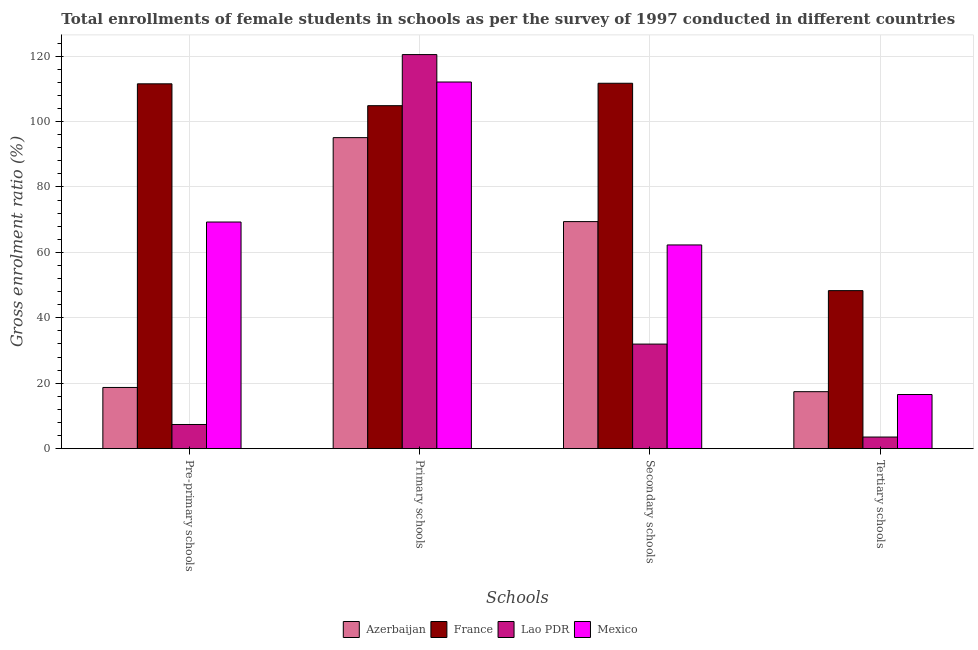Are the number of bars per tick equal to the number of legend labels?
Provide a succinct answer. Yes. Are the number of bars on each tick of the X-axis equal?
Offer a terse response. Yes. What is the label of the 3rd group of bars from the left?
Your answer should be very brief. Secondary schools. What is the gross enrolment ratio(female) in pre-primary schools in Azerbaijan?
Offer a terse response. 18.71. Across all countries, what is the maximum gross enrolment ratio(female) in tertiary schools?
Your answer should be very brief. 48.31. Across all countries, what is the minimum gross enrolment ratio(female) in primary schools?
Keep it short and to the point. 95.08. In which country was the gross enrolment ratio(female) in primary schools maximum?
Ensure brevity in your answer.  Lao PDR. In which country was the gross enrolment ratio(female) in secondary schools minimum?
Your answer should be compact. Lao PDR. What is the total gross enrolment ratio(female) in tertiary schools in the graph?
Make the answer very short. 85.84. What is the difference between the gross enrolment ratio(female) in pre-primary schools in Mexico and that in Azerbaijan?
Your answer should be compact. 50.57. What is the difference between the gross enrolment ratio(female) in secondary schools in France and the gross enrolment ratio(female) in pre-primary schools in Azerbaijan?
Your answer should be very brief. 92.99. What is the average gross enrolment ratio(female) in pre-primary schools per country?
Offer a very short reply. 51.73. What is the difference between the gross enrolment ratio(female) in secondary schools and gross enrolment ratio(female) in pre-primary schools in Azerbaijan?
Give a very brief answer. 50.7. In how many countries, is the gross enrolment ratio(female) in tertiary schools greater than 104 %?
Your response must be concise. 0. What is the ratio of the gross enrolment ratio(female) in secondary schools in Mexico to that in France?
Make the answer very short. 0.56. Is the gross enrolment ratio(female) in primary schools in Mexico less than that in France?
Keep it short and to the point. No. Is the difference between the gross enrolment ratio(female) in pre-primary schools in Azerbaijan and Mexico greater than the difference between the gross enrolment ratio(female) in secondary schools in Azerbaijan and Mexico?
Offer a very short reply. No. What is the difference between the highest and the second highest gross enrolment ratio(female) in secondary schools?
Make the answer very short. 42.29. What is the difference between the highest and the lowest gross enrolment ratio(female) in pre-primary schools?
Make the answer very short. 104.14. In how many countries, is the gross enrolment ratio(female) in secondary schools greater than the average gross enrolment ratio(female) in secondary schools taken over all countries?
Offer a terse response. 2. What does the 1st bar from the left in Pre-primary schools represents?
Ensure brevity in your answer.  Azerbaijan. What does the 2nd bar from the right in Secondary schools represents?
Provide a short and direct response. Lao PDR. Is it the case that in every country, the sum of the gross enrolment ratio(female) in pre-primary schools and gross enrolment ratio(female) in primary schools is greater than the gross enrolment ratio(female) in secondary schools?
Your response must be concise. Yes. How many bars are there?
Offer a terse response. 16. How many countries are there in the graph?
Offer a very short reply. 4. Are the values on the major ticks of Y-axis written in scientific E-notation?
Ensure brevity in your answer.  No. Does the graph contain grids?
Your answer should be very brief. Yes. Where does the legend appear in the graph?
Provide a short and direct response. Bottom center. How many legend labels are there?
Offer a very short reply. 4. How are the legend labels stacked?
Provide a short and direct response. Horizontal. What is the title of the graph?
Give a very brief answer. Total enrollments of female students in schools as per the survey of 1997 conducted in different countries. Does "Moldova" appear as one of the legend labels in the graph?
Provide a short and direct response. No. What is the label or title of the X-axis?
Ensure brevity in your answer.  Schools. What is the label or title of the Y-axis?
Your answer should be compact. Gross enrolment ratio (%). What is the Gross enrolment ratio (%) of Azerbaijan in Pre-primary schools?
Provide a succinct answer. 18.71. What is the Gross enrolment ratio (%) in France in Pre-primary schools?
Provide a short and direct response. 111.53. What is the Gross enrolment ratio (%) in Lao PDR in Pre-primary schools?
Provide a short and direct response. 7.39. What is the Gross enrolment ratio (%) of Mexico in Pre-primary schools?
Offer a very short reply. 69.28. What is the Gross enrolment ratio (%) of Azerbaijan in Primary schools?
Your response must be concise. 95.08. What is the Gross enrolment ratio (%) of France in Primary schools?
Your answer should be very brief. 104.85. What is the Gross enrolment ratio (%) in Lao PDR in Primary schools?
Keep it short and to the point. 120.47. What is the Gross enrolment ratio (%) in Mexico in Primary schools?
Provide a short and direct response. 112.09. What is the Gross enrolment ratio (%) in Azerbaijan in Secondary schools?
Your answer should be very brief. 69.41. What is the Gross enrolment ratio (%) in France in Secondary schools?
Offer a terse response. 111.7. What is the Gross enrolment ratio (%) of Lao PDR in Secondary schools?
Make the answer very short. 31.97. What is the Gross enrolment ratio (%) of Mexico in Secondary schools?
Keep it short and to the point. 62.28. What is the Gross enrolment ratio (%) in Azerbaijan in Tertiary schools?
Provide a short and direct response. 17.43. What is the Gross enrolment ratio (%) in France in Tertiary schools?
Provide a succinct answer. 48.31. What is the Gross enrolment ratio (%) of Lao PDR in Tertiary schools?
Offer a very short reply. 3.56. What is the Gross enrolment ratio (%) in Mexico in Tertiary schools?
Your answer should be very brief. 16.55. Across all Schools, what is the maximum Gross enrolment ratio (%) of Azerbaijan?
Your answer should be compact. 95.08. Across all Schools, what is the maximum Gross enrolment ratio (%) in France?
Your response must be concise. 111.7. Across all Schools, what is the maximum Gross enrolment ratio (%) of Lao PDR?
Offer a terse response. 120.47. Across all Schools, what is the maximum Gross enrolment ratio (%) of Mexico?
Provide a succinct answer. 112.09. Across all Schools, what is the minimum Gross enrolment ratio (%) of Azerbaijan?
Provide a succinct answer. 17.43. Across all Schools, what is the minimum Gross enrolment ratio (%) in France?
Your response must be concise. 48.31. Across all Schools, what is the minimum Gross enrolment ratio (%) in Lao PDR?
Ensure brevity in your answer.  3.56. Across all Schools, what is the minimum Gross enrolment ratio (%) of Mexico?
Provide a succinct answer. 16.55. What is the total Gross enrolment ratio (%) in Azerbaijan in the graph?
Your answer should be very brief. 200.63. What is the total Gross enrolment ratio (%) in France in the graph?
Your response must be concise. 376.4. What is the total Gross enrolment ratio (%) of Lao PDR in the graph?
Offer a terse response. 163.39. What is the total Gross enrolment ratio (%) in Mexico in the graph?
Your answer should be very brief. 260.2. What is the difference between the Gross enrolment ratio (%) in Azerbaijan in Pre-primary schools and that in Primary schools?
Your answer should be compact. -76.37. What is the difference between the Gross enrolment ratio (%) in France in Pre-primary schools and that in Primary schools?
Ensure brevity in your answer.  6.68. What is the difference between the Gross enrolment ratio (%) in Lao PDR in Pre-primary schools and that in Primary schools?
Keep it short and to the point. -113.08. What is the difference between the Gross enrolment ratio (%) of Mexico in Pre-primary schools and that in Primary schools?
Offer a very short reply. -42.8. What is the difference between the Gross enrolment ratio (%) in Azerbaijan in Pre-primary schools and that in Secondary schools?
Offer a very short reply. -50.7. What is the difference between the Gross enrolment ratio (%) of France in Pre-primary schools and that in Secondary schools?
Keep it short and to the point. -0.17. What is the difference between the Gross enrolment ratio (%) of Lao PDR in Pre-primary schools and that in Secondary schools?
Your response must be concise. -24.58. What is the difference between the Gross enrolment ratio (%) of Mexico in Pre-primary schools and that in Secondary schools?
Give a very brief answer. 7.01. What is the difference between the Gross enrolment ratio (%) of Azerbaijan in Pre-primary schools and that in Tertiary schools?
Give a very brief answer. 1.29. What is the difference between the Gross enrolment ratio (%) in France in Pre-primary schools and that in Tertiary schools?
Give a very brief answer. 63.22. What is the difference between the Gross enrolment ratio (%) in Lao PDR in Pre-primary schools and that in Tertiary schools?
Your response must be concise. 3.84. What is the difference between the Gross enrolment ratio (%) of Mexico in Pre-primary schools and that in Tertiary schools?
Your answer should be very brief. 52.73. What is the difference between the Gross enrolment ratio (%) in Azerbaijan in Primary schools and that in Secondary schools?
Keep it short and to the point. 25.67. What is the difference between the Gross enrolment ratio (%) of France in Primary schools and that in Secondary schools?
Keep it short and to the point. -6.85. What is the difference between the Gross enrolment ratio (%) in Lao PDR in Primary schools and that in Secondary schools?
Keep it short and to the point. 88.5. What is the difference between the Gross enrolment ratio (%) of Mexico in Primary schools and that in Secondary schools?
Provide a succinct answer. 49.81. What is the difference between the Gross enrolment ratio (%) in Azerbaijan in Primary schools and that in Tertiary schools?
Offer a very short reply. 77.66. What is the difference between the Gross enrolment ratio (%) of France in Primary schools and that in Tertiary schools?
Ensure brevity in your answer.  56.54. What is the difference between the Gross enrolment ratio (%) of Lao PDR in Primary schools and that in Tertiary schools?
Offer a terse response. 116.91. What is the difference between the Gross enrolment ratio (%) of Mexico in Primary schools and that in Tertiary schools?
Your response must be concise. 95.53. What is the difference between the Gross enrolment ratio (%) in Azerbaijan in Secondary schools and that in Tertiary schools?
Offer a terse response. 51.99. What is the difference between the Gross enrolment ratio (%) of France in Secondary schools and that in Tertiary schools?
Your answer should be very brief. 63.39. What is the difference between the Gross enrolment ratio (%) of Lao PDR in Secondary schools and that in Tertiary schools?
Your response must be concise. 28.42. What is the difference between the Gross enrolment ratio (%) of Mexico in Secondary schools and that in Tertiary schools?
Your answer should be compact. 45.73. What is the difference between the Gross enrolment ratio (%) in Azerbaijan in Pre-primary schools and the Gross enrolment ratio (%) in France in Primary schools?
Ensure brevity in your answer.  -86.14. What is the difference between the Gross enrolment ratio (%) of Azerbaijan in Pre-primary schools and the Gross enrolment ratio (%) of Lao PDR in Primary schools?
Make the answer very short. -101.76. What is the difference between the Gross enrolment ratio (%) of Azerbaijan in Pre-primary schools and the Gross enrolment ratio (%) of Mexico in Primary schools?
Provide a short and direct response. -93.38. What is the difference between the Gross enrolment ratio (%) in France in Pre-primary schools and the Gross enrolment ratio (%) in Lao PDR in Primary schools?
Make the answer very short. -8.94. What is the difference between the Gross enrolment ratio (%) of France in Pre-primary schools and the Gross enrolment ratio (%) of Mexico in Primary schools?
Give a very brief answer. -0.56. What is the difference between the Gross enrolment ratio (%) in Lao PDR in Pre-primary schools and the Gross enrolment ratio (%) in Mexico in Primary schools?
Your answer should be very brief. -104.69. What is the difference between the Gross enrolment ratio (%) of Azerbaijan in Pre-primary schools and the Gross enrolment ratio (%) of France in Secondary schools?
Offer a very short reply. -92.99. What is the difference between the Gross enrolment ratio (%) of Azerbaijan in Pre-primary schools and the Gross enrolment ratio (%) of Lao PDR in Secondary schools?
Your response must be concise. -13.26. What is the difference between the Gross enrolment ratio (%) of Azerbaijan in Pre-primary schools and the Gross enrolment ratio (%) of Mexico in Secondary schools?
Provide a succinct answer. -43.57. What is the difference between the Gross enrolment ratio (%) of France in Pre-primary schools and the Gross enrolment ratio (%) of Lao PDR in Secondary schools?
Make the answer very short. 79.56. What is the difference between the Gross enrolment ratio (%) in France in Pre-primary schools and the Gross enrolment ratio (%) in Mexico in Secondary schools?
Provide a short and direct response. 49.25. What is the difference between the Gross enrolment ratio (%) of Lao PDR in Pre-primary schools and the Gross enrolment ratio (%) of Mexico in Secondary schools?
Offer a very short reply. -54.88. What is the difference between the Gross enrolment ratio (%) of Azerbaijan in Pre-primary schools and the Gross enrolment ratio (%) of France in Tertiary schools?
Make the answer very short. -29.6. What is the difference between the Gross enrolment ratio (%) of Azerbaijan in Pre-primary schools and the Gross enrolment ratio (%) of Lao PDR in Tertiary schools?
Ensure brevity in your answer.  15.16. What is the difference between the Gross enrolment ratio (%) in Azerbaijan in Pre-primary schools and the Gross enrolment ratio (%) in Mexico in Tertiary schools?
Provide a succinct answer. 2.16. What is the difference between the Gross enrolment ratio (%) in France in Pre-primary schools and the Gross enrolment ratio (%) in Lao PDR in Tertiary schools?
Ensure brevity in your answer.  107.98. What is the difference between the Gross enrolment ratio (%) of France in Pre-primary schools and the Gross enrolment ratio (%) of Mexico in Tertiary schools?
Provide a succinct answer. 94.98. What is the difference between the Gross enrolment ratio (%) in Lao PDR in Pre-primary schools and the Gross enrolment ratio (%) in Mexico in Tertiary schools?
Ensure brevity in your answer.  -9.16. What is the difference between the Gross enrolment ratio (%) in Azerbaijan in Primary schools and the Gross enrolment ratio (%) in France in Secondary schools?
Offer a very short reply. -16.62. What is the difference between the Gross enrolment ratio (%) in Azerbaijan in Primary schools and the Gross enrolment ratio (%) in Lao PDR in Secondary schools?
Provide a succinct answer. 63.11. What is the difference between the Gross enrolment ratio (%) in Azerbaijan in Primary schools and the Gross enrolment ratio (%) in Mexico in Secondary schools?
Give a very brief answer. 32.81. What is the difference between the Gross enrolment ratio (%) in France in Primary schools and the Gross enrolment ratio (%) in Lao PDR in Secondary schools?
Your response must be concise. 72.88. What is the difference between the Gross enrolment ratio (%) of France in Primary schools and the Gross enrolment ratio (%) of Mexico in Secondary schools?
Your answer should be very brief. 42.57. What is the difference between the Gross enrolment ratio (%) of Lao PDR in Primary schools and the Gross enrolment ratio (%) of Mexico in Secondary schools?
Provide a succinct answer. 58.19. What is the difference between the Gross enrolment ratio (%) of Azerbaijan in Primary schools and the Gross enrolment ratio (%) of France in Tertiary schools?
Make the answer very short. 46.77. What is the difference between the Gross enrolment ratio (%) of Azerbaijan in Primary schools and the Gross enrolment ratio (%) of Lao PDR in Tertiary schools?
Your response must be concise. 91.53. What is the difference between the Gross enrolment ratio (%) in Azerbaijan in Primary schools and the Gross enrolment ratio (%) in Mexico in Tertiary schools?
Keep it short and to the point. 78.53. What is the difference between the Gross enrolment ratio (%) in France in Primary schools and the Gross enrolment ratio (%) in Lao PDR in Tertiary schools?
Make the answer very short. 101.29. What is the difference between the Gross enrolment ratio (%) of France in Primary schools and the Gross enrolment ratio (%) of Mexico in Tertiary schools?
Your answer should be compact. 88.3. What is the difference between the Gross enrolment ratio (%) of Lao PDR in Primary schools and the Gross enrolment ratio (%) of Mexico in Tertiary schools?
Offer a terse response. 103.92. What is the difference between the Gross enrolment ratio (%) in Azerbaijan in Secondary schools and the Gross enrolment ratio (%) in France in Tertiary schools?
Give a very brief answer. 21.1. What is the difference between the Gross enrolment ratio (%) in Azerbaijan in Secondary schools and the Gross enrolment ratio (%) in Lao PDR in Tertiary schools?
Your answer should be compact. 65.86. What is the difference between the Gross enrolment ratio (%) of Azerbaijan in Secondary schools and the Gross enrolment ratio (%) of Mexico in Tertiary schools?
Keep it short and to the point. 52.86. What is the difference between the Gross enrolment ratio (%) of France in Secondary schools and the Gross enrolment ratio (%) of Lao PDR in Tertiary schools?
Provide a short and direct response. 108.15. What is the difference between the Gross enrolment ratio (%) in France in Secondary schools and the Gross enrolment ratio (%) in Mexico in Tertiary schools?
Your response must be concise. 95.15. What is the difference between the Gross enrolment ratio (%) in Lao PDR in Secondary schools and the Gross enrolment ratio (%) in Mexico in Tertiary schools?
Make the answer very short. 15.42. What is the average Gross enrolment ratio (%) of Azerbaijan per Schools?
Your answer should be compact. 50.16. What is the average Gross enrolment ratio (%) in France per Schools?
Give a very brief answer. 94.1. What is the average Gross enrolment ratio (%) in Lao PDR per Schools?
Your answer should be compact. 40.85. What is the average Gross enrolment ratio (%) of Mexico per Schools?
Your answer should be very brief. 65.05. What is the difference between the Gross enrolment ratio (%) of Azerbaijan and Gross enrolment ratio (%) of France in Pre-primary schools?
Your response must be concise. -92.82. What is the difference between the Gross enrolment ratio (%) in Azerbaijan and Gross enrolment ratio (%) in Lao PDR in Pre-primary schools?
Your answer should be very brief. 11.32. What is the difference between the Gross enrolment ratio (%) of Azerbaijan and Gross enrolment ratio (%) of Mexico in Pre-primary schools?
Offer a terse response. -50.57. What is the difference between the Gross enrolment ratio (%) of France and Gross enrolment ratio (%) of Lao PDR in Pre-primary schools?
Provide a succinct answer. 104.14. What is the difference between the Gross enrolment ratio (%) of France and Gross enrolment ratio (%) of Mexico in Pre-primary schools?
Ensure brevity in your answer.  42.25. What is the difference between the Gross enrolment ratio (%) of Lao PDR and Gross enrolment ratio (%) of Mexico in Pre-primary schools?
Offer a terse response. -61.89. What is the difference between the Gross enrolment ratio (%) in Azerbaijan and Gross enrolment ratio (%) in France in Primary schools?
Your response must be concise. -9.77. What is the difference between the Gross enrolment ratio (%) in Azerbaijan and Gross enrolment ratio (%) in Lao PDR in Primary schools?
Provide a short and direct response. -25.39. What is the difference between the Gross enrolment ratio (%) in Azerbaijan and Gross enrolment ratio (%) in Mexico in Primary schools?
Your answer should be very brief. -17. What is the difference between the Gross enrolment ratio (%) in France and Gross enrolment ratio (%) in Lao PDR in Primary schools?
Your answer should be very brief. -15.62. What is the difference between the Gross enrolment ratio (%) in France and Gross enrolment ratio (%) in Mexico in Primary schools?
Give a very brief answer. -7.24. What is the difference between the Gross enrolment ratio (%) of Lao PDR and Gross enrolment ratio (%) of Mexico in Primary schools?
Give a very brief answer. 8.38. What is the difference between the Gross enrolment ratio (%) in Azerbaijan and Gross enrolment ratio (%) in France in Secondary schools?
Provide a succinct answer. -42.29. What is the difference between the Gross enrolment ratio (%) in Azerbaijan and Gross enrolment ratio (%) in Lao PDR in Secondary schools?
Offer a very short reply. 37.44. What is the difference between the Gross enrolment ratio (%) in Azerbaijan and Gross enrolment ratio (%) in Mexico in Secondary schools?
Offer a very short reply. 7.14. What is the difference between the Gross enrolment ratio (%) in France and Gross enrolment ratio (%) in Lao PDR in Secondary schools?
Make the answer very short. 79.73. What is the difference between the Gross enrolment ratio (%) of France and Gross enrolment ratio (%) of Mexico in Secondary schools?
Provide a succinct answer. 49.43. What is the difference between the Gross enrolment ratio (%) of Lao PDR and Gross enrolment ratio (%) of Mexico in Secondary schools?
Provide a succinct answer. -30.31. What is the difference between the Gross enrolment ratio (%) in Azerbaijan and Gross enrolment ratio (%) in France in Tertiary schools?
Your answer should be compact. -30.89. What is the difference between the Gross enrolment ratio (%) of Azerbaijan and Gross enrolment ratio (%) of Lao PDR in Tertiary schools?
Offer a terse response. 13.87. What is the difference between the Gross enrolment ratio (%) of Azerbaijan and Gross enrolment ratio (%) of Mexico in Tertiary schools?
Provide a succinct answer. 0.87. What is the difference between the Gross enrolment ratio (%) of France and Gross enrolment ratio (%) of Lao PDR in Tertiary schools?
Offer a terse response. 44.76. What is the difference between the Gross enrolment ratio (%) in France and Gross enrolment ratio (%) in Mexico in Tertiary schools?
Your answer should be very brief. 31.76. What is the difference between the Gross enrolment ratio (%) of Lao PDR and Gross enrolment ratio (%) of Mexico in Tertiary schools?
Make the answer very short. -13. What is the ratio of the Gross enrolment ratio (%) of Azerbaijan in Pre-primary schools to that in Primary schools?
Your response must be concise. 0.2. What is the ratio of the Gross enrolment ratio (%) in France in Pre-primary schools to that in Primary schools?
Offer a terse response. 1.06. What is the ratio of the Gross enrolment ratio (%) of Lao PDR in Pre-primary schools to that in Primary schools?
Offer a very short reply. 0.06. What is the ratio of the Gross enrolment ratio (%) in Mexico in Pre-primary schools to that in Primary schools?
Offer a terse response. 0.62. What is the ratio of the Gross enrolment ratio (%) of Azerbaijan in Pre-primary schools to that in Secondary schools?
Keep it short and to the point. 0.27. What is the ratio of the Gross enrolment ratio (%) of Lao PDR in Pre-primary schools to that in Secondary schools?
Your response must be concise. 0.23. What is the ratio of the Gross enrolment ratio (%) of Mexico in Pre-primary schools to that in Secondary schools?
Your answer should be compact. 1.11. What is the ratio of the Gross enrolment ratio (%) in Azerbaijan in Pre-primary schools to that in Tertiary schools?
Keep it short and to the point. 1.07. What is the ratio of the Gross enrolment ratio (%) of France in Pre-primary schools to that in Tertiary schools?
Offer a very short reply. 2.31. What is the ratio of the Gross enrolment ratio (%) in Lao PDR in Pre-primary schools to that in Tertiary schools?
Your answer should be compact. 2.08. What is the ratio of the Gross enrolment ratio (%) of Mexico in Pre-primary schools to that in Tertiary schools?
Give a very brief answer. 4.19. What is the ratio of the Gross enrolment ratio (%) of Azerbaijan in Primary schools to that in Secondary schools?
Give a very brief answer. 1.37. What is the ratio of the Gross enrolment ratio (%) in France in Primary schools to that in Secondary schools?
Offer a very short reply. 0.94. What is the ratio of the Gross enrolment ratio (%) of Lao PDR in Primary schools to that in Secondary schools?
Keep it short and to the point. 3.77. What is the ratio of the Gross enrolment ratio (%) in Mexico in Primary schools to that in Secondary schools?
Your answer should be very brief. 1.8. What is the ratio of the Gross enrolment ratio (%) of Azerbaijan in Primary schools to that in Tertiary schools?
Make the answer very short. 5.46. What is the ratio of the Gross enrolment ratio (%) of France in Primary schools to that in Tertiary schools?
Provide a succinct answer. 2.17. What is the ratio of the Gross enrolment ratio (%) of Lao PDR in Primary schools to that in Tertiary schools?
Give a very brief answer. 33.88. What is the ratio of the Gross enrolment ratio (%) in Mexico in Primary schools to that in Tertiary schools?
Your answer should be very brief. 6.77. What is the ratio of the Gross enrolment ratio (%) of Azerbaijan in Secondary schools to that in Tertiary schools?
Keep it short and to the point. 3.98. What is the ratio of the Gross enrolment ratio (%) in France in Secondary schools to that in Tertiary schools?
Offer a terse response. 2.31. What is the ratio of the Gross enrolment ratio (%) of Lao PDR in Secondary schools to that in Tertiary schools?
Make the answer very short. 8.99. What is the ratio of the Gross enrolment ratio (%) in Mexico in Secondary schools to that in Tertiary schools?
Provide a short and direct response. 3.76. What is the difference between the highest and the second highest Gross enrolment ratio (%) in Azerbaijan?
Provide a succinct answer. 25.67. What is the difference between the highest and the second highest Gross enrolment ratio (%) in France?
Keep it short and to the point. 0.17. What is the difference between the highest and the second highest Gross enrolment ratio (%) of Lao PDR?
Give a very brief answer. 88.5. What is the difference between the highest and the second highest Gross enrolment ratio (%) of Mexico?
Give a very brief answer. 42.8. What is the difference between the highest and the lowest Gross enrolment ratio (%) of Azerbaijan?
Provide a short and direct response. 77.66. What is the difference between the highest and the lowest Gross enrolment ratio (%) of France?
Keep it short and to the point. 63.39. What is the difference between the highest and the lowest Gross enrolment ratio (%) of Lao PDR?
Provide a succinct answer. 116.91. What is the difference between the highest and the lowest Gross enrolment ratio (%) of Mexico?
Provide a succinct answer. 95.53. 